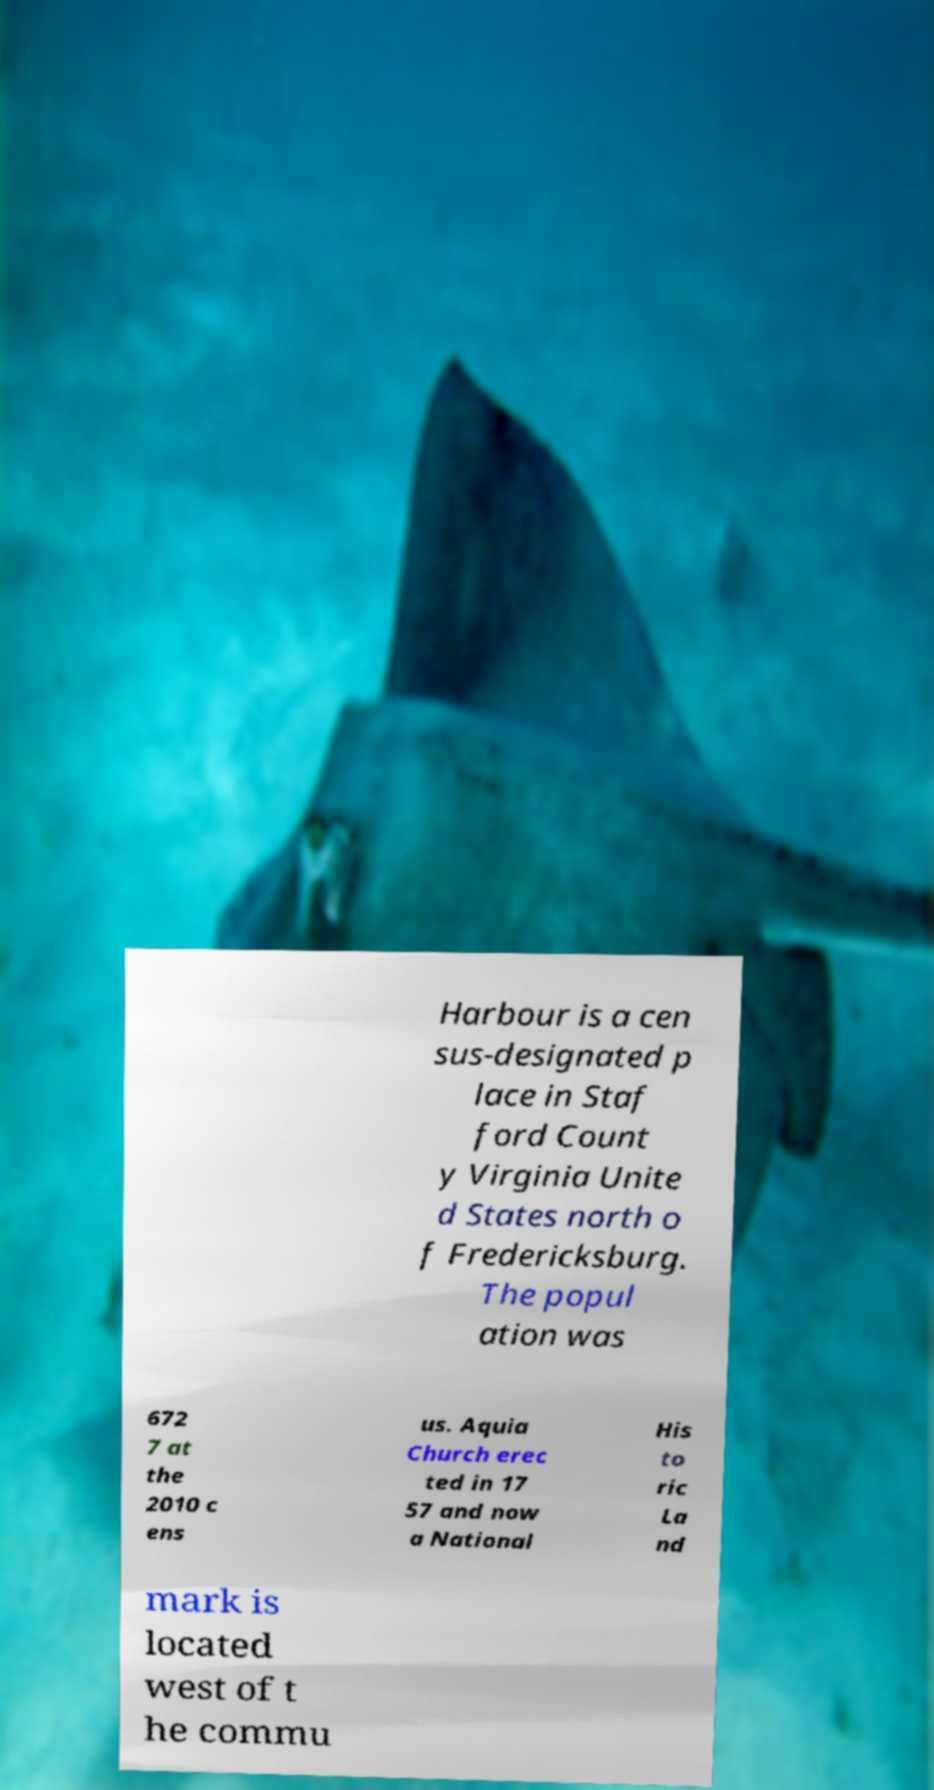Could you assist in decoding the text presented in this image and type it out clearly? Harbour is a cen sus-designated p lace in Staf ford Count y Virginia Unite d States north o f Fredericksburg. The popul ation was 672 7 at the 2010 c ens us. Aquia Church erec ted in 17 57 and now a National His to ric La nd mark is located west of t he commu 